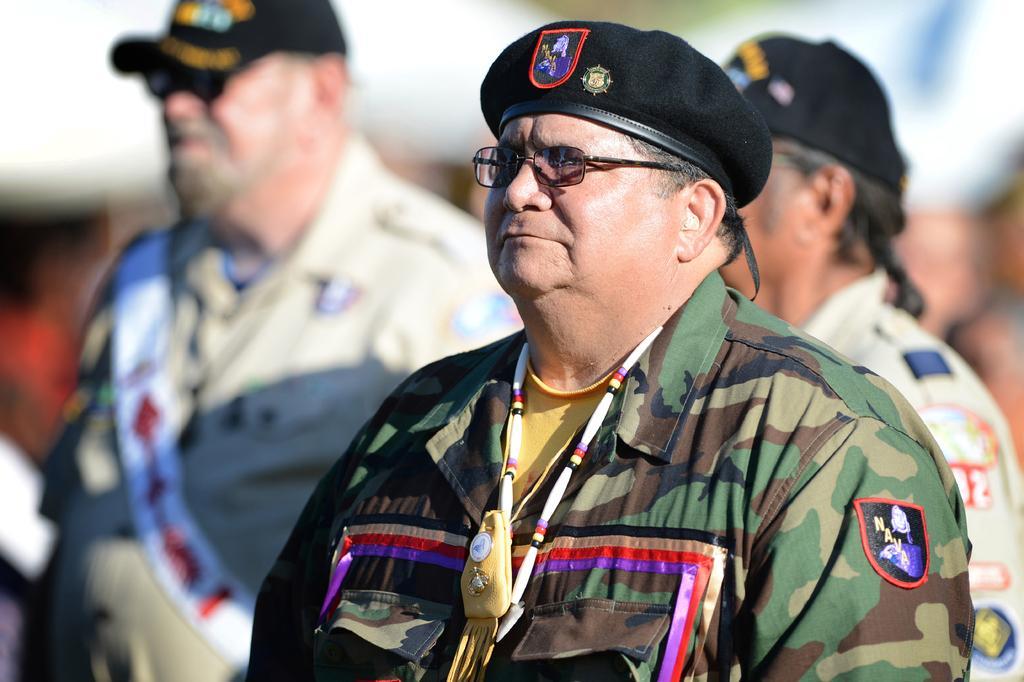Describe this image in one or two sentences. Here in this picture we can see a group of people standing over there and we can see all of them are having military uniform on them and all of them are wearing caps on them and we can see couple of people are having spectacles on them over there. 